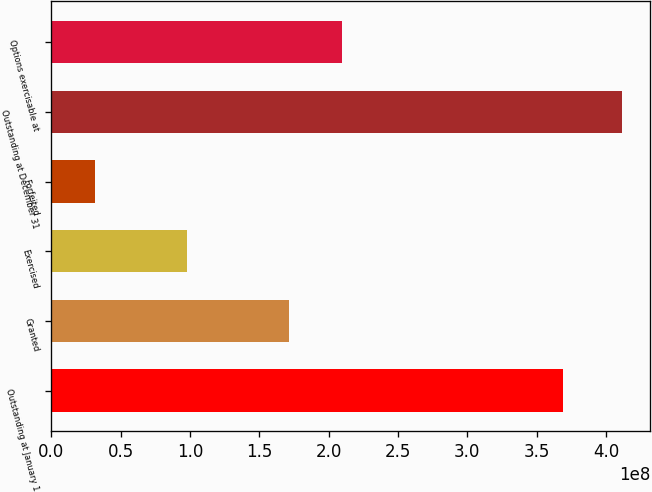Convert chart to OTSL. <chart><loc_0><loc_0><loc_500><loc_500><bar_chart><fcel>Outstanding at January 1<fcel>Granted<fcel>Exercised<fcel>Forfeited<fcel>Outstanding at December 31<fcel>Options exercisable at<nl><fcel>3.691e+08<fcel>1.71671e+08<fcel>9.81164e+07<fcel>3.12078e+07<fcel>4.11447e+08<fcel>2.09695e+08<nl></chart> 